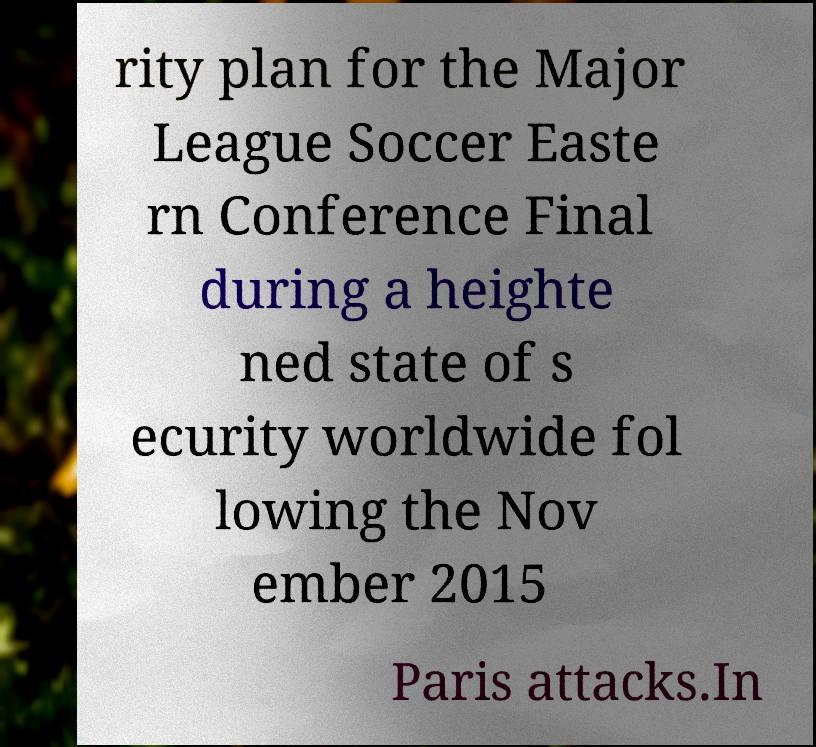There's text embedded in this image that I need extracted. Can you transcribe it verbatim? rity plan for the Major League Soccer Easte rn Conference Final during a heighte ned state of s ecurity worldwide fol lowing the Nov ember 2015 Paris attacks.In 